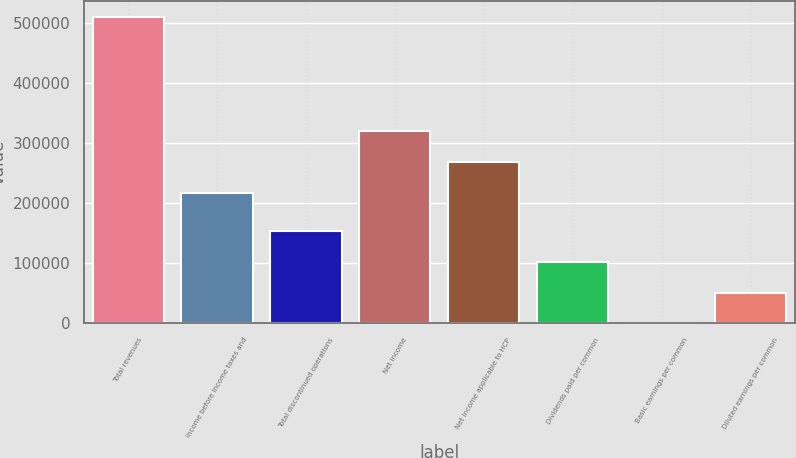Convert chart. <chart><loc_0><loc_0><loc_500><loc_500><bar_chart><fcel>Total revenues<fcel>Income before income taxes and<fcel>Total discontinued operations<fcel>Net income<fcel>Net income applicable to HCP<fcel>Dividends paid per common<fcel>Basic earnings per common<fcel>Diluted earnings per common<nl><fcel>511184<fcel>217667<fcel>153356<fcel>319904<fcel>268785<fcel>102237<fcel>0.51<fcel>51118.9<nl></chart> 